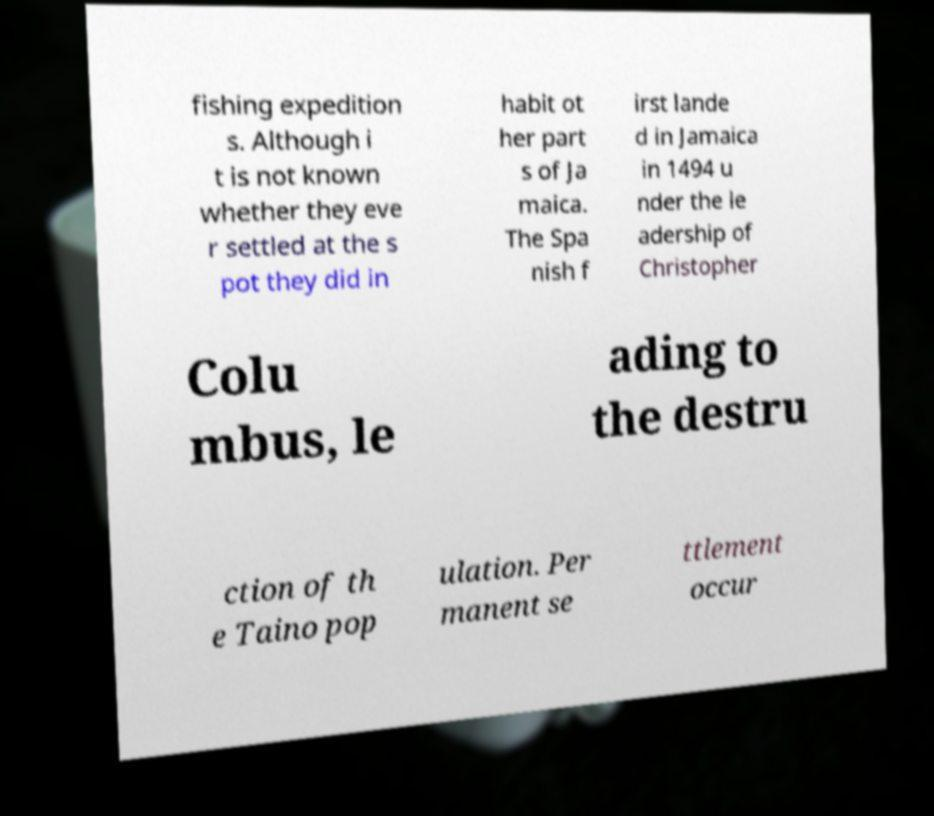Could you extract and type out the text from this image? fishing expedition s. Although i t is not known whether they eve r settled at the s pot they did in habit ot her part s of Ja maica. The Spa nish f irst lande d in Jamaica in 1494 u nder the le adership of Christopher Colu mbus, le ading to the destru ction of th e Taino pop ulation. Per manent se ttlement occur 